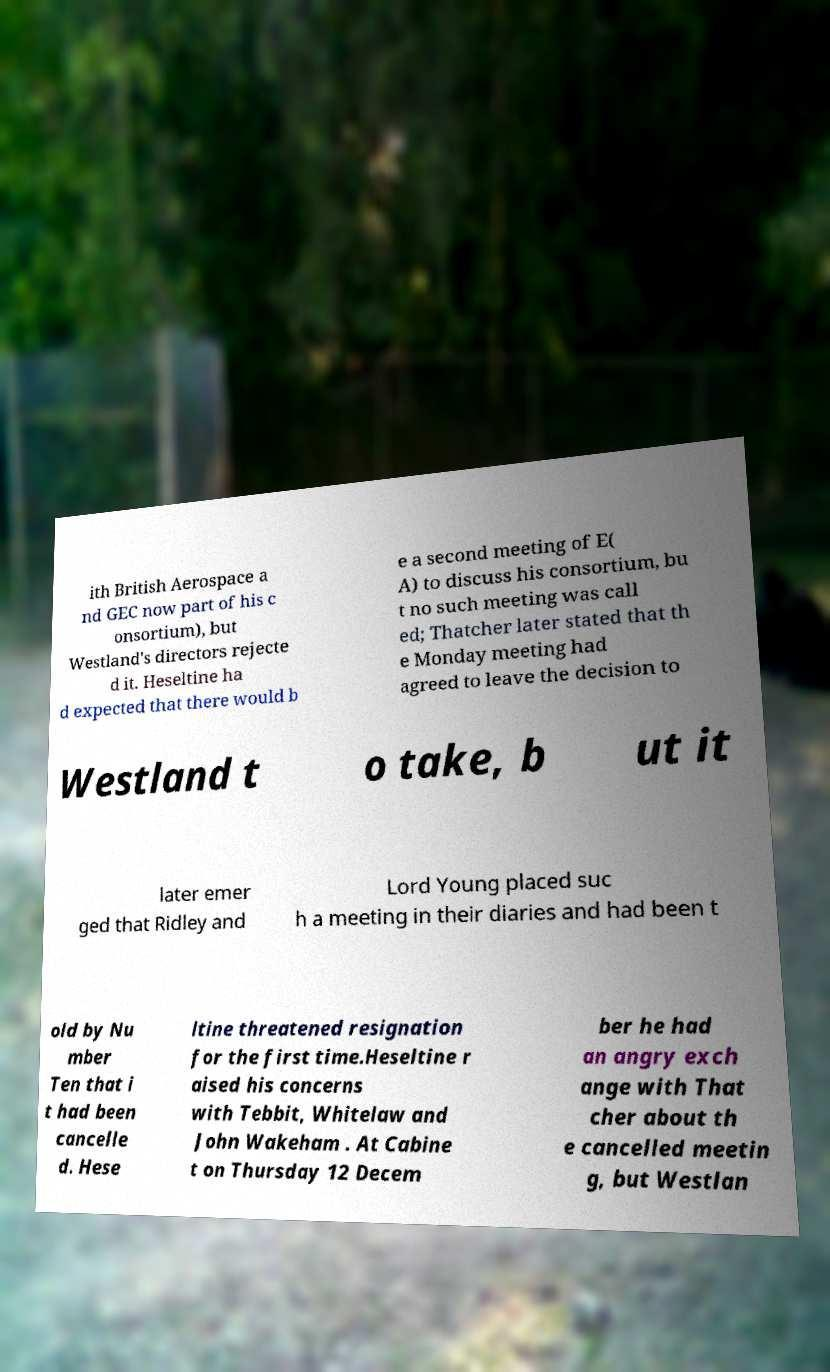There's text embedded in this image that I need extracted. Can you transcribe it verbatim? ith British Aerospace a nd GEC now part of his c onsortium), but Westland's directors rejecte d it. Heseltine ha d expected that there would b e a second meeting of E( A) to discuss his consortium, bu t no such meeting was call ed; Thatcher later stated that th e Monday meeting had agreed to leave the decision to Westland t o take, b ut it later emer ged that Ridley and Lord Young placed suc h a meeting in their diaries and had been t old by Nu mber Ten that i t had been cancelle d. Hese ltine threatened resignation for the first time.Heseltine r aised his concerns with Tebbit, Whitelaw and John Wakeham . At Cabine t on Thursday 12 Decem ber he had an angry exch ange with That cher about th e cancelled meetin g, but Westlan 